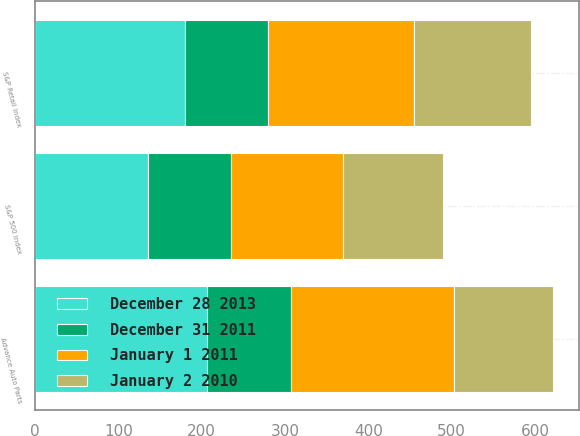Convert chart to OTSL. <chart><loc_0><loc_0><loc_500><loc_500><stacked_bar_chart><ecel><fcel>Advance Auto Parts<fcel>S&P 500 Index<fcel>S&P Retail Index<nl><fcel>December 31 2011<fcel>100<fcel>100<fcel>100<nl><fcel>January 2 2010<fcel>119.28<fcel>119.67<fcel>141.28<nl><fcel>January 1 2011<fcel>195.8<fcel>134.97<fcel>174.7<nl><fcel>December 28 2013<fcel>206.86<fcel>134.96<fcel>179.79<nl></chart> 